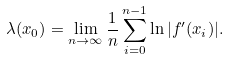<formula> <loc_0><loc_0><loc_500><loc_500>\lambda ( x _ { 0 } ) = \lim _ { n \to \infty } \frac { 1 } { n } \sum _ { i = 0 } ^ { n - 1 } \ln | f ^ { \prime } ( x _ { i } ) | .</formula> 